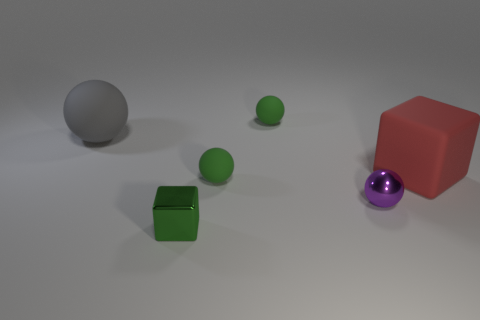What is the color of the tiny matte ball in front of the large red block?
Offer a terse response. Green. Is there anything else that has the same color as the tiny cube?
Give a very brief answer. Yes. Does the metallic ball have the same size as the green metal thing?
Ensure brevity in your answer.  Yes. What is the size of the green object that is in front of the big red object and behind the tiny green cube?
Provide a short and direct response. Small. What number of gray balls are the same material as the tiny green cube?
Offer a very short reply. 0. The small shiny ball has what color?
Your answer should be very brief. Purple. There is a tiny green thing that is behind the gray matte sphere; does it have the same shape as the gray object?
Give a very brief answer. Yes. How many things are large matte things that are right of the purple shiny sphere or matte balls?
Give a very brief answer. 4. Are there any green matte things of the same shape as the red matte object?
Give a very brief answer. No. There is another metal thing that is the same size as the purple thing; what shape is it?
Provide a short and direct response. Cube. 